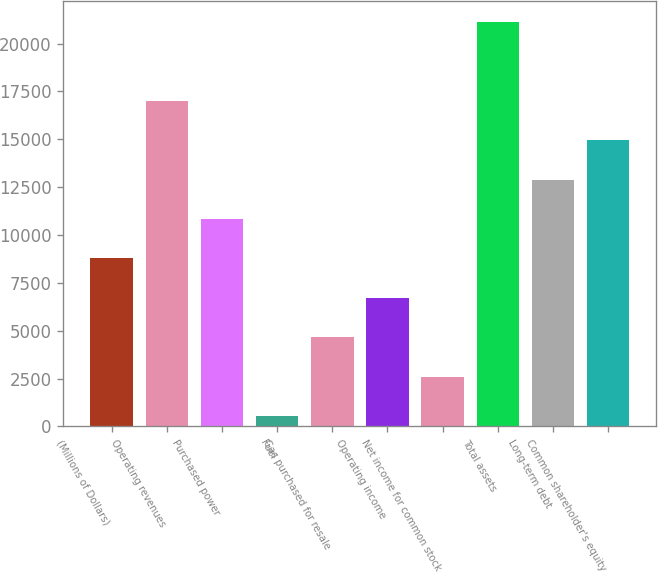<chart> <loc_0><loc_0><loc_500><loc_500><bar_chart><fcel>(Millions of Dollars)<fcel>Operating revenues<fcel>Purchased power<fcel>Fuel<fcel>Gas purchased for resale<fcel>Operating income<fcel>Net income for common stock<fcel>Total assets<fcel>Long-term debt<fcel>Common shareholder's equity<nl><fcel>8773.2<fcel>17020.4<fcel>10835<fcel>526<fcel>4649.6<fcel>6711.4<fcel>2587.8<fcel>21144<fcel>12896.8<fcel>14958.6<nl></chart> 